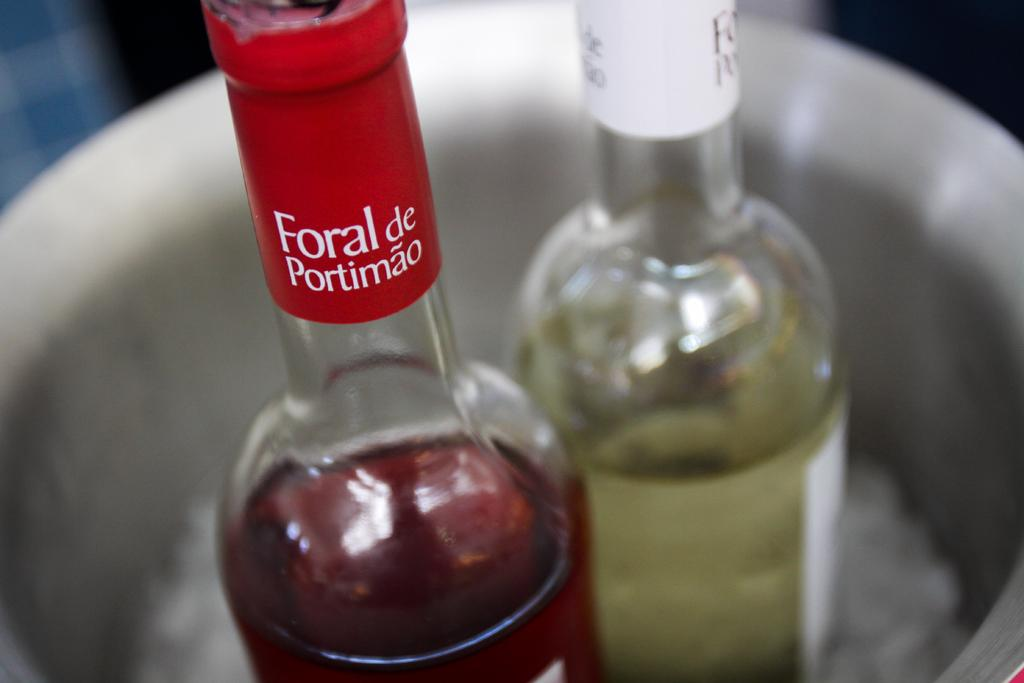Provide a one-sentence caption for the provided image. A red and a white wine bottle sit in an ice bucket - the red wine is Foral de Portimao. 